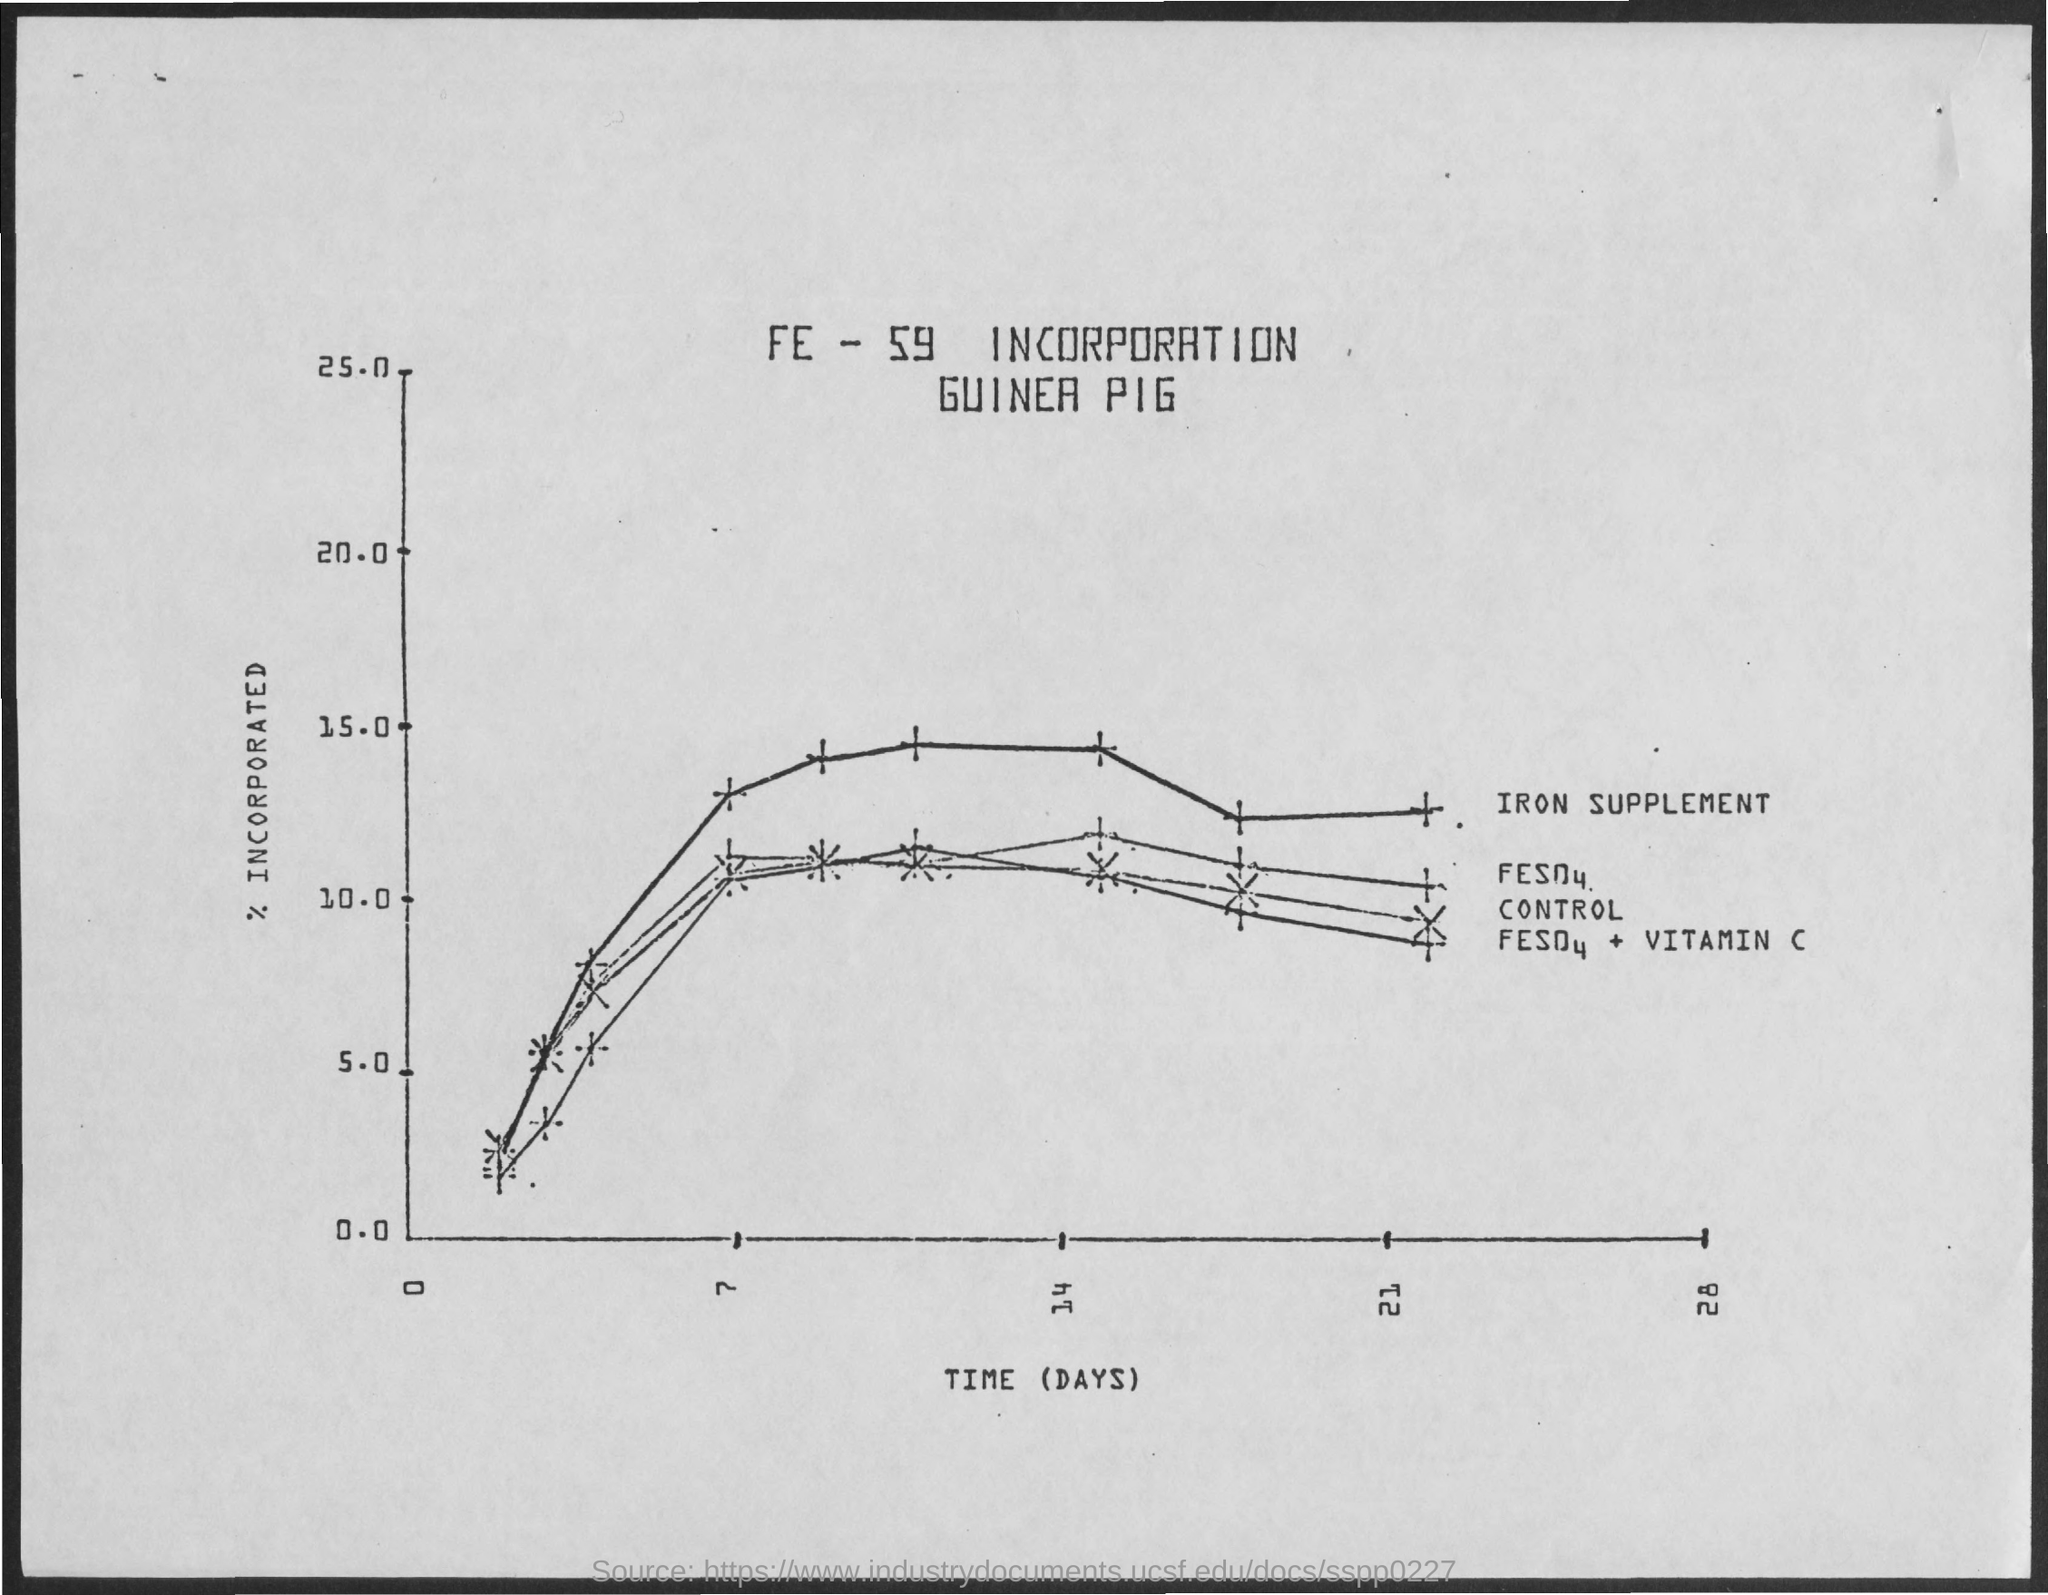Give some essential details in this illustration. The y-axis displays the percentage of individuals who have been integrated into society. The x-axis represents time (in days) and displays the plotted information. 